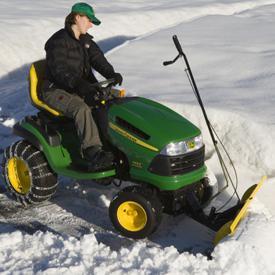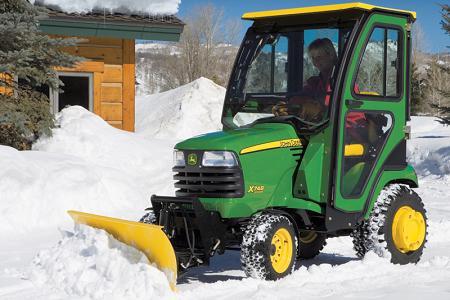The first image is the image on the left, the second image is the image on the right. Evaluate the accuracy of this statement regarding the images: "An image shows a leftward-facing green tractor plowing snowy ground.". Is it true? Answer yes or no. Yes. The first image is the image on the left, the second image is the image on the right. Examine the images to the left and right. Is the description "In one image, a person wearing a coat and hat is plowing snow using a green tractor with yellow snow blade." accurate? Answer yes or no. Yes. 